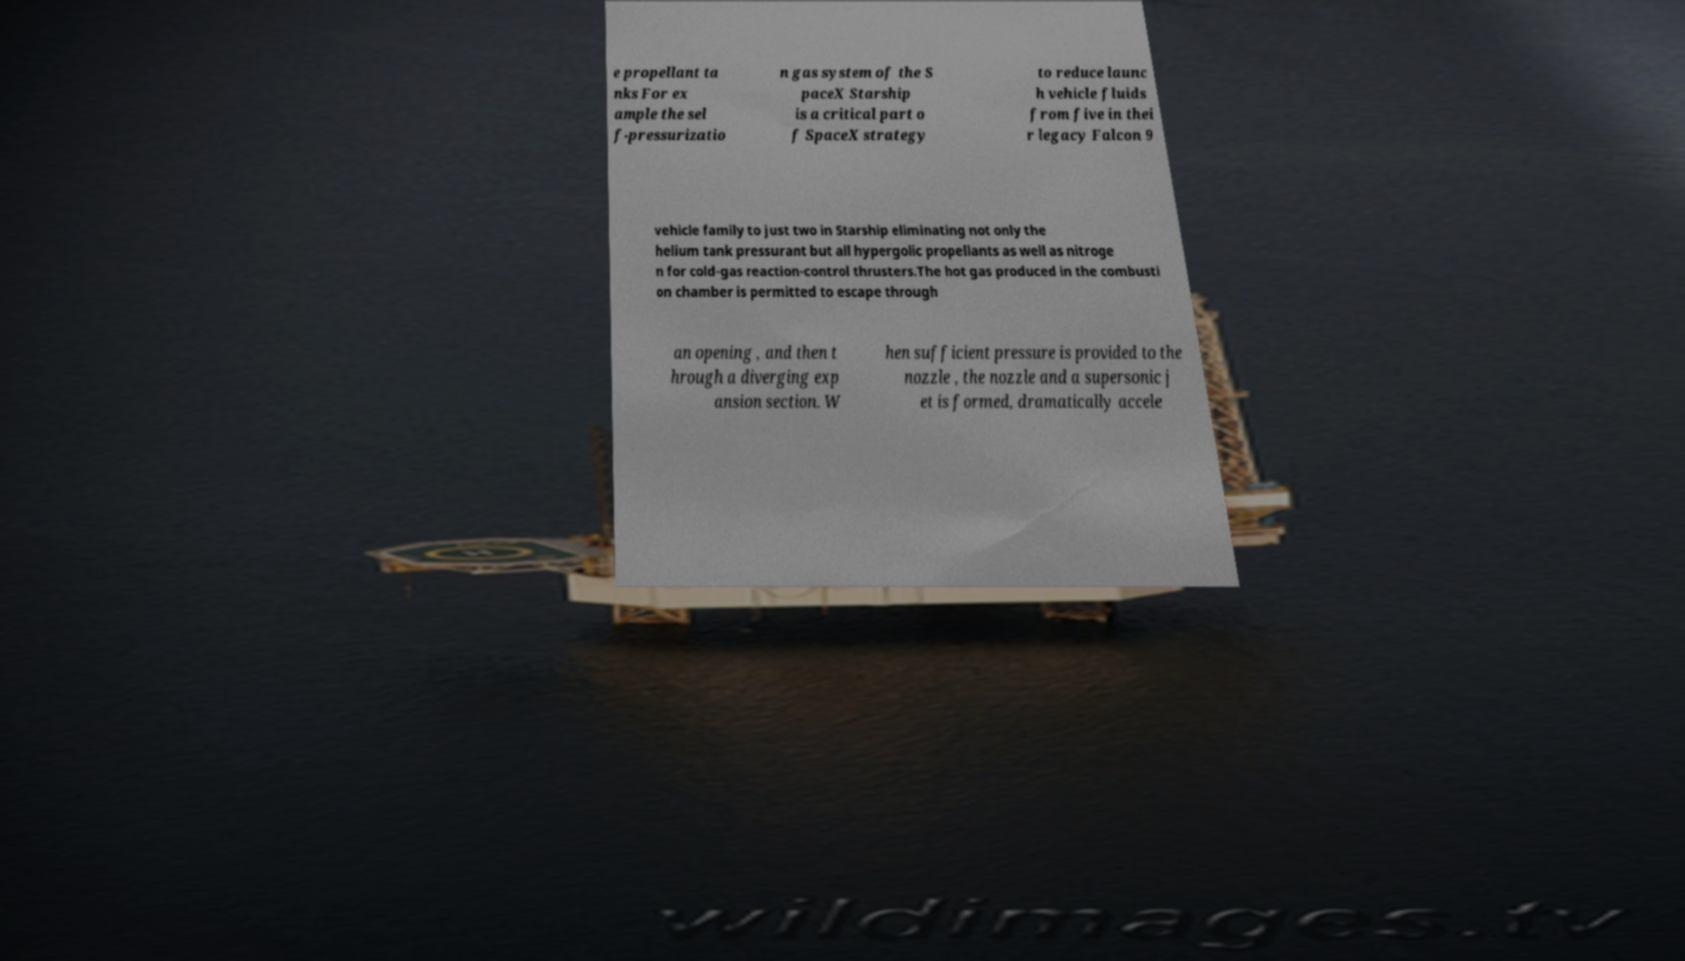Could you extract and type out the text from this image? e propellant ta nks For ex ample the sel f-pressurizatio n gas system of the S paceX Starship is a critical part o f SpaceX strategy to reduce launc h vehicle fluids from five in thei r legacy Falcon 9 vehicle family to just two in Starship eliminating not only the helium tank pressurant but all hypergolic propellants as well as nitroge n for cold-gas reaction-control thrusters.The hot gas produced in the combusti on chamber is permitted to escape through an opening , and then t hrough a diverging exp ansion section. W hen sufficient pressure is provided to the nozzle , the nozzle and a supersonic j et is formed, dramatically accele 